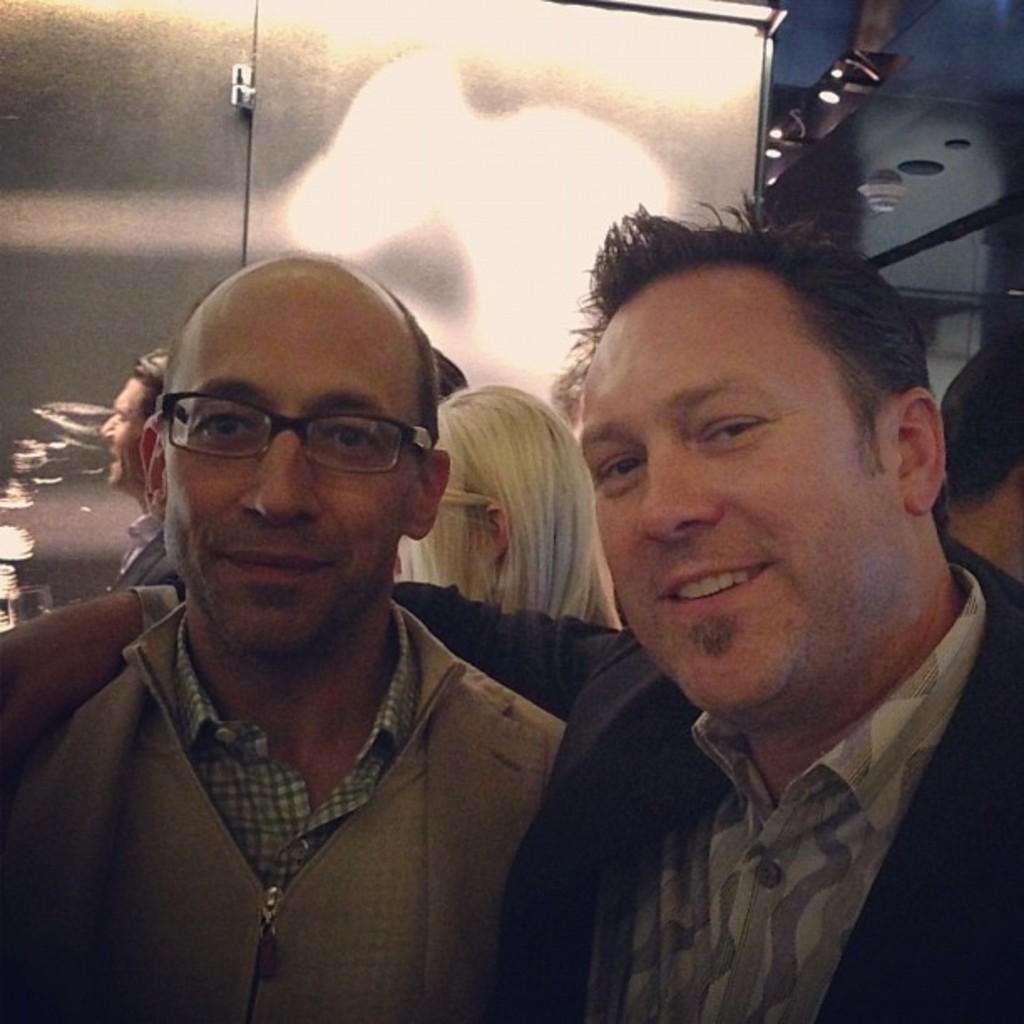Can you describe this image briefly? In this picture we can see two people, they are smiling, one person is wearing a spectacles and in the background we can see a group of people, roof, lights and some objects. 